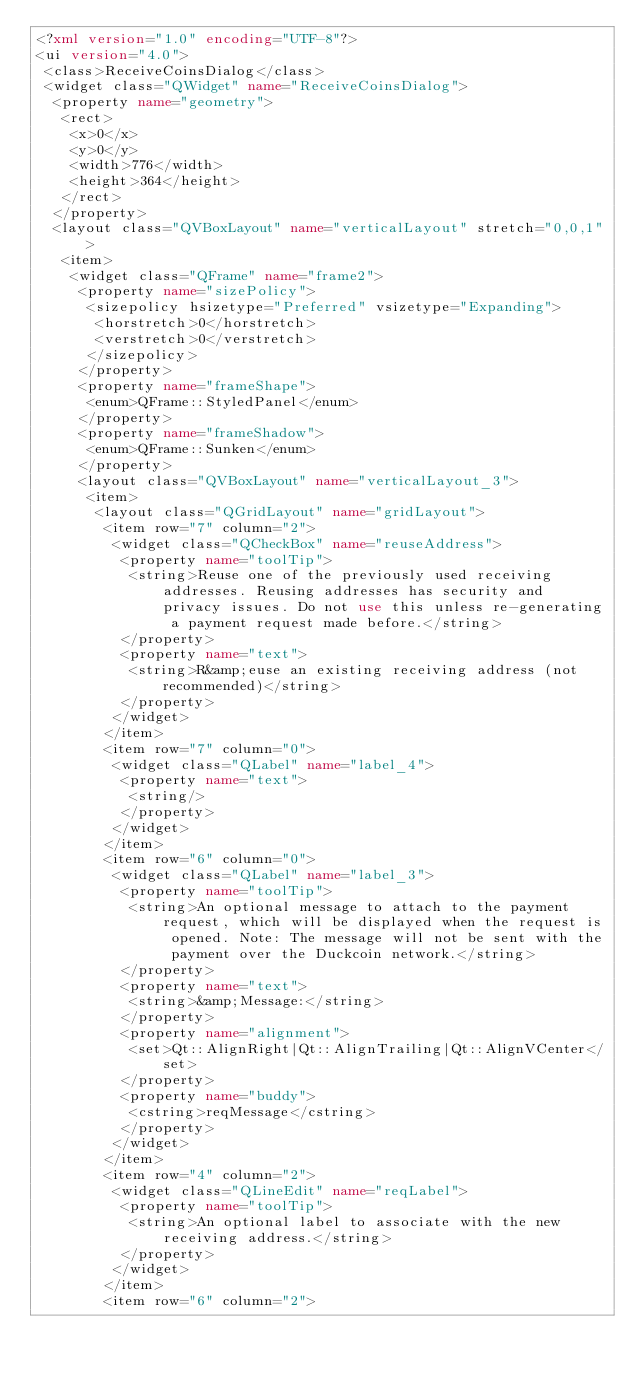<code> <loc_0><loc_0><loc_500><loc_500><_XML_><?xml version="1.0" encoding="UTF-8"?>
<ui version="4.0">
 <class>ReceiveCoinsDialog</class>
 <widget class="QWidget" name="ReceiveCoinsDialog">
  <property name="geometry">
   <rect>
    <x>0</x>
    <y>0</y>
    <width>776</width>
    <height>364</height>
   </rect>
  </property>
  <layout class="QVBoxLayout" name="verticalLayout" stretch="0,0,1">
   <item>
    <widget class="QFrame" name="frame2">
     <property name="sizePolicy">
      <sizepolicy hsizetype="Preferred" vsizetype="Expanding">
       <horstretch>0</horstretch>
       <verstretch>0</verstretch>
      </sizepolicy>
     </property>
     <property name="frameShape">
      <enum>QFrame::StyledPanel</enum>
     </property>
     <property name="frameShadow">
      <enum>QFrame::Sunken</enum>
     </property>
     <layout class="QVBoxLayout" name="verticalLayout_3">
      <item>
       <layout class="QGridLayout" name="gridLayout">
        <item row="7" column="2">
         <widget class="QCheckBox" name="reuseAddress">
          <property name="toolTip">
           <string>Reuse one of the previously used receiving addresses. Reusing addresses has security and privacy issues. Do not use this unless re-generating a payment request made before.</string>
          </property>
          <property name="text">
           <string>R&amp;euse an existing receiving address (not recommended)</string>
          </property>
         </widget>
        </item>
        <item row="7" column="0">
         <widget class="QLabel" name="label_4">
          <property name="text">
           <string/>
          </property>
         </widget>
        </item>
        <item row="6" column="0">
         <widget class="QLabel" name="label_3">
          <property name="toolTip">
           <string>An optional message to attach to the payment request, which will be displayed when the request is opened. Note: The message will not be sent with the payment over the Duckcoin network.</string>
          </property>
          <property name="text">
           <string>&amp;Message:</string>
          </property>
          <property name="alignment">
           <set>Qt::AlignRight|Qt::AlignTrailing|Qt::AlignVCenter</set>
          </property>
          <property name="buddy">
           <cstring>reqMessage</cstring>
          </property>
         </widget>
        </item>
        <item row="4" column="2">
         <widget class="QLineEdit" name="reqLabel">
          <property name="toolTip">
           <string>An optional label to associate with the new receiving address.</string>
          </property>
         </widget>
        </item>
        <item row="6" column="2"></code> 